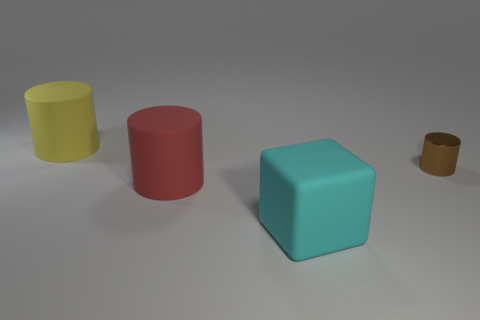Add 3 red cylinders. How many objects exist? 7 Subtract all cylinders. How many objects are left? 1 Subtract all cyan objects. Subtract all large red cylinders. How many objects are left? 2 Add 2 big rubber things. How many big rubber things are left? 5 Add 2 purple spheres. How many purple spheres exist? 2 Subtract 0 blue cylinders. How many objects are left? 4 